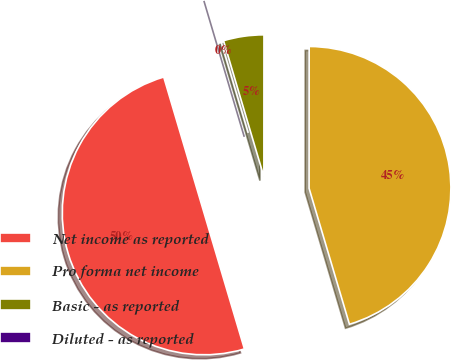Convert chart to OTSL. <chart><loc_0><loc_0><loc_500><loc_500><pie_chart><fcel>Net income as reported<fcel>Pro forma net income<fcel>Basic - as reported<fcel>Diluted - as reported<nl><fcel>50.0%<fcel>45.4%<fcel>4.6%<fcel>0.0%<nl></chart> 